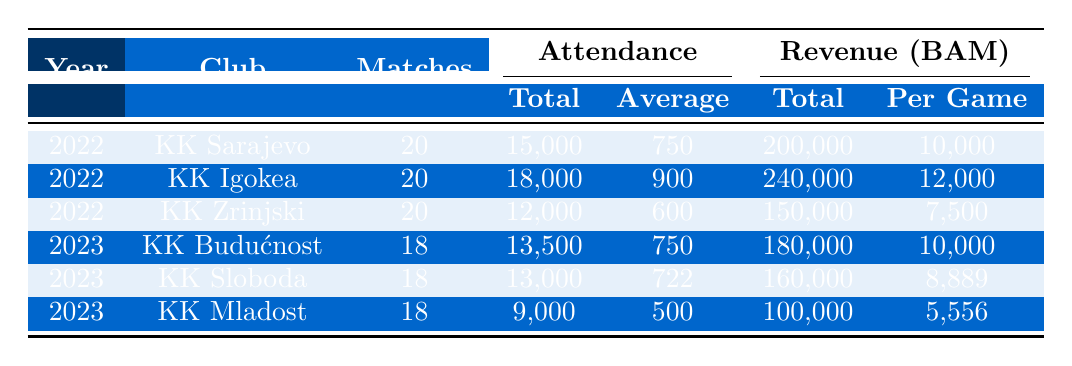What is the total attendance for KK Igokea in 2022? The total attendance for KK Igokea in the table is directly listed under the Total Attendance column, which is 18,000.
Answer: 18,000 What was the total revenue for KK Mladost in 2023? The total revenue for KK Mladost is shown in the Revenue section under Total, which indicates 100,000 BAM.
Answer: 100,000 BAM Which club had the highest average attendance in 2022? We need to compare the average attendance values for all clubs in 2022: KK Sarajevo (750), KK Igokea (900), and KK Zrinjski (600). The highest is 900 for KK Igokea.
Answer: KK Igokea How many matches did KK Sloboda play in total? The number of matches played by KK Sloboda is listed in the Matches column, which is 18.
Answer: 18 Which club had the lowest average revenue per game in 2023? To find the lowest average revenue per game, we compare the values for each club in 2023: KK Budućnost (10,000), KK Sloboda (8,889), and KK Mladost (5,556). The lowest is 5,556 for KK Mladost.
Answer: KK Mladost What is the percentage difference in total revenue between KK Igokea in 2022 and KK Budućnost in 2023? First, we find the revenue for both clubs: KK Igokea had 240,000 BAM, and KK Budućnost had 180,000 BAM. The difference is 240,000 - 180,000 = 60,000. The percentage difference is (60,000 / 240,000) * 100, which is 25%.
Answer: 25% Is the average attendance for KK Zrinjski higher than the average attendance for KK Sloboda in 2023? KK Zrinjski's average attendance is 600 (from 2022) and KK Sloboda's is 722 (from 2023). Since 600 is less than 722, the statement is false.
Answer: No What was the total attendance for all clubs in 2022 combined? To find this, we sum the total attendance for all clubs in 2022: 15,000 (KK Sarajevo) + 18,000 (KK Igokea) + 12,000 (KK Zrinjski) = 45,000.
Answer: 45,000 Which club had the highest total attendance in 2023? We look at the Total Attendance column for 2023: KK Budućnost (13,500), KK Sloboda (13,000), and KK Mladost (9,000). The highest total attendance is from KK Budućnost at 13,500.
Answer: KK Budućnost What is the average revenue per game for KK Zrinjski in 2022? For KK Zrinjski, the Average Revenue Per Game is given in the Revenue section, which is 7,500 BAM.
Answer: 7,500 BAM 